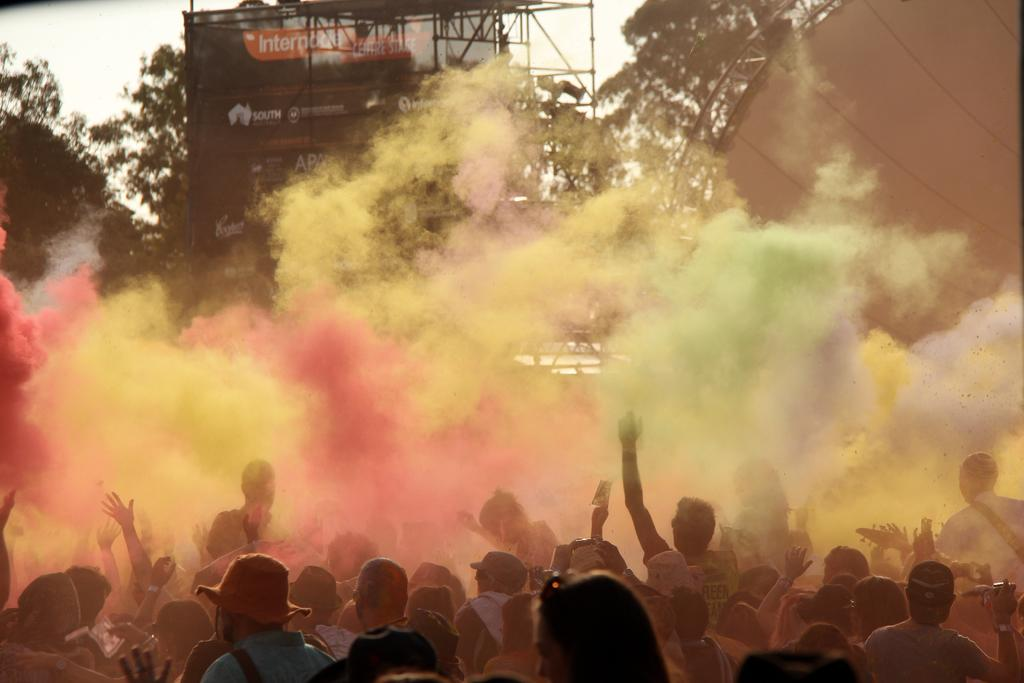Who or what can be seen at the bottom of the image? There are persons visible at the bottom of the image. What is visible at the top of the image? The sky is visible at the top of the image. What type of advertising or promotional material is present in the image? There is a hoarding board in the image. What unique visual element is present in the middle of the image? There is colorful fog in the middle of the image. What is the texture of the afterthought in the middle of the image? There is no afterthought present in the image; it is a metaphorical term and not a visual element. What thing is responsible for creating the colorful fog in the middle of the image? The provided facts do not mention any specific thing responsible for creating the colorful fog in the image. 